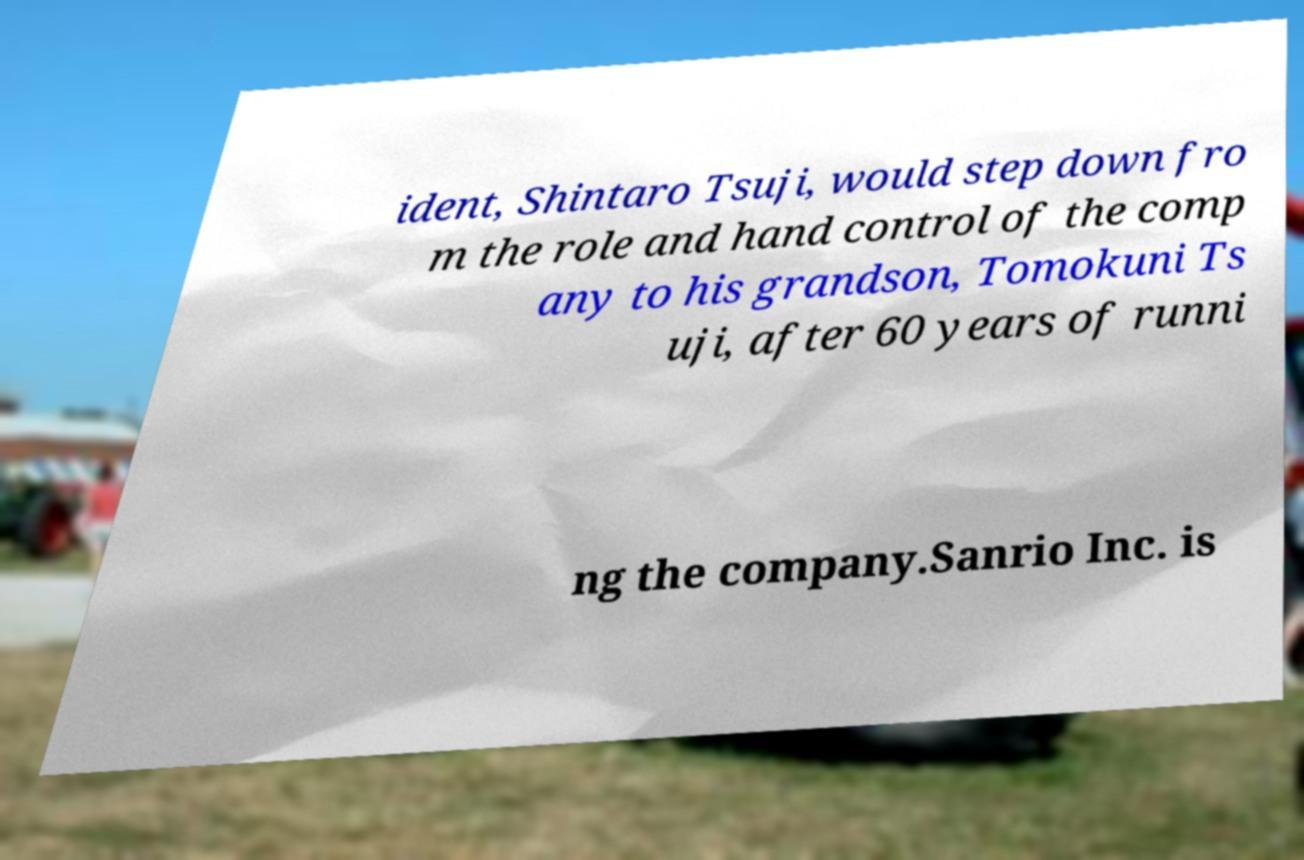Please read and relay the text visible in this image. What does it say? ident, Shintaro Tsuji, would step down fro m the role and hand control of the comp any to his grandson, Tomokuni Ts uji, after 60 years of runni ng the company.Sanrio Inc. is 